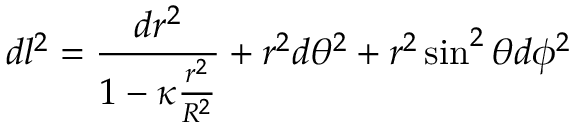<formula> <loc_0><loc_0><loc_500><loc_500>d l ^ { 2 } = { \frac { d r ^ { 2 } } { 1 - \kappa { \frac { r ^ { 2 } } { R ^ { 2 } } } } } + r ^ { 2 } d \theta ^ { 2 } + r ^ { 2 } \sin ^ { 2 } \theta d \phi ^ { 2 }</formula> 